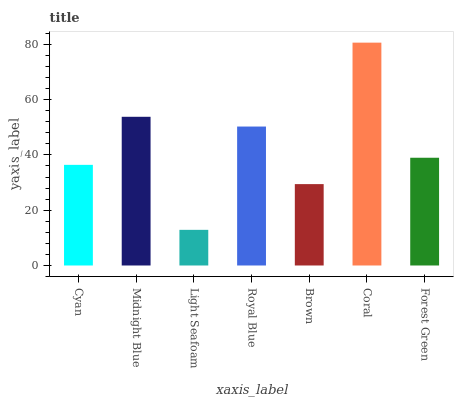Is Light Seafoam the minimum?
Answer yes or no. Yes. Is Coral the maximum?
Answer yes or no. Yes. Is Midnight Blue the minimum?
Answer yes or no. No. Is Midnight Blue the maximum?
Answer yes or no. No. Is Midnight Blue greater than Cyan?
Answer yes or no. Yes. Is Cyan less than Midnight Blue?
Answer yes or no. Yes. Is Cyan greater than Midnight Blue?
Answer yes or no. No. Is Midnight Blue less than Cyan?
Answer yes or no. No. Is Forest Green the high median?
Answer yes or no. Yes. Is Forest Green the low median?
Answer yes or no. Yes. Is Cyan the high median?
Answer yes or no. No. Is Light Seafoam the low median?
Answer yes or no. No. 